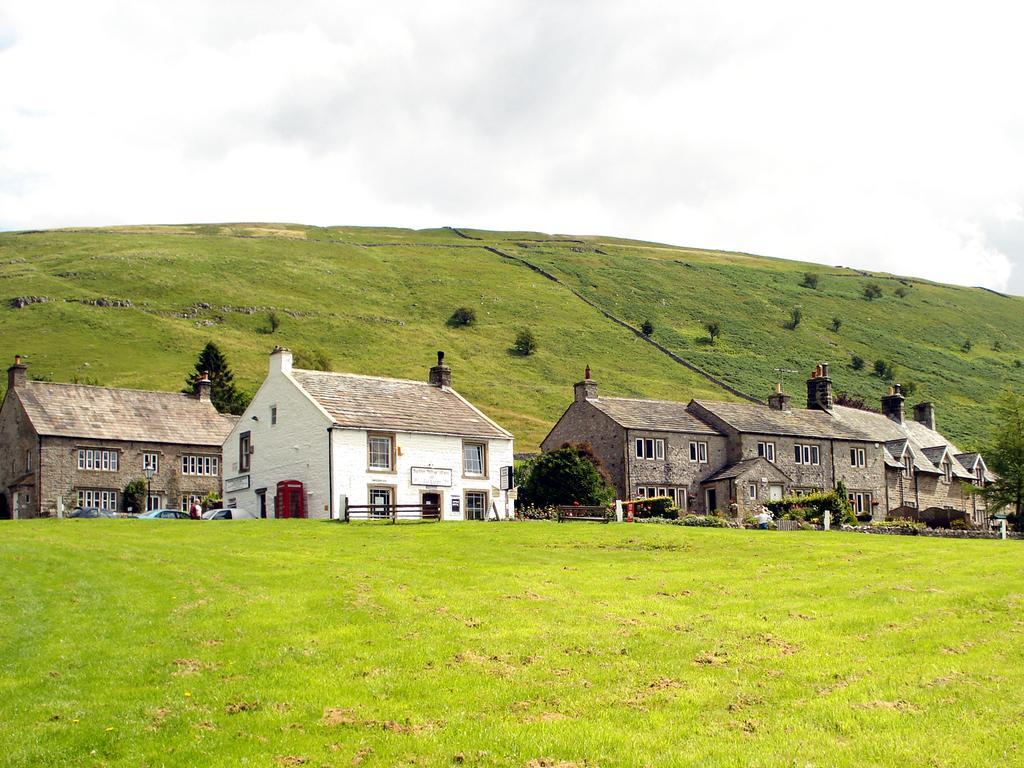Can you describe this image briefly? In this image we can see a garden ,and in the middle we can see the houses. 